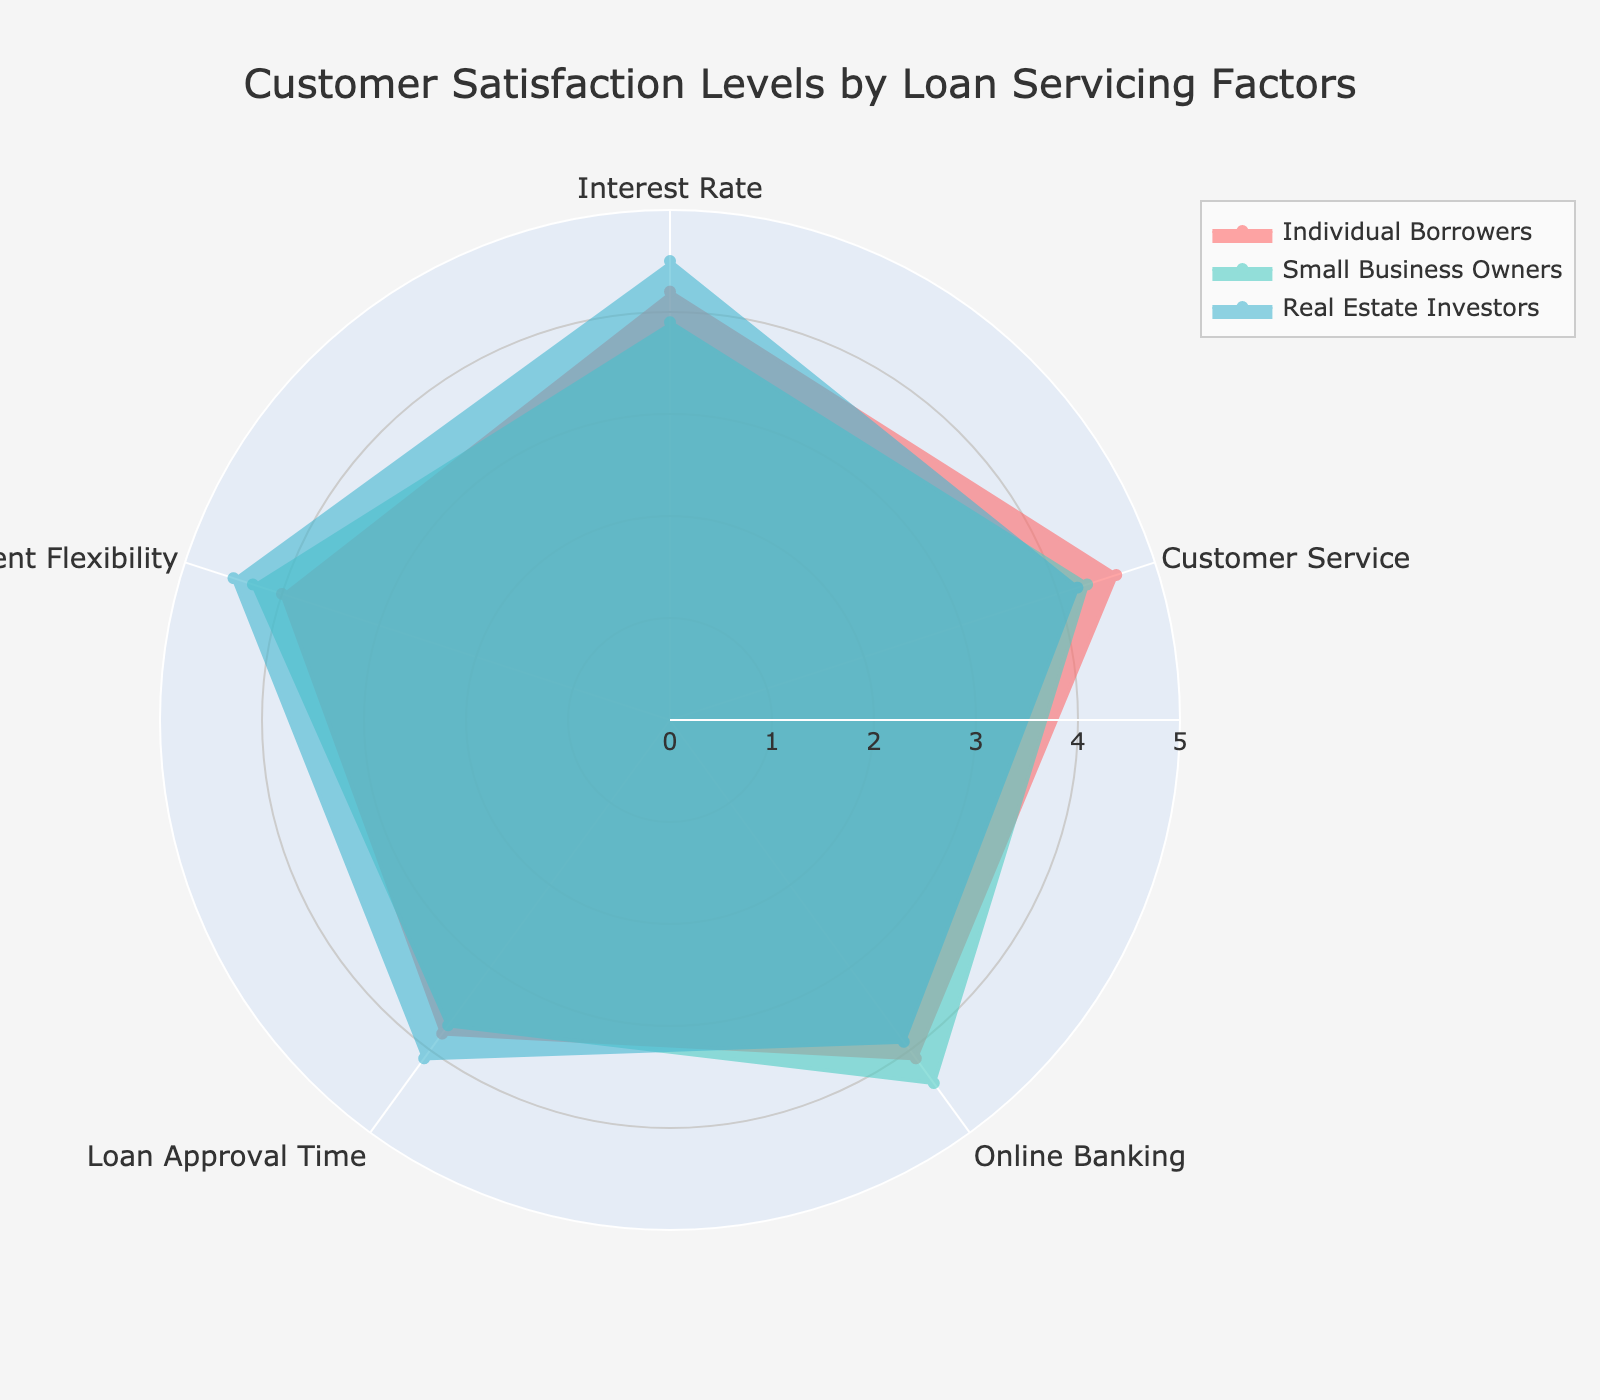What is the title of the radar chart? The title of a chart is typically found at the top, summarizing the chart's content. Here, it reads "Customer Satisfaction Levels by Loan Servicing Factors."
Answer: Customer Satisfaction Levels by Loan Servicing Factors How many customer groups are represented in the radar chart? The legend often indicates the groups represented. Here, there are three: Individual Borrowers, Small Business Owners, and Real Estate Investors.
Answer: 3 Which customer group has the highest satisfaction level for "Interest Rate"? Review the points for "Interest Rate" in the chart. The highest value is 4.5, which belongs to the Real Estate Investors.
Answer: Real Estate Investors What's the average satisfaction level across all factors for Individual Borrowers? Sum the values for Individual Borrowers across the five factors and divide by 5. (4.2 + 4.6 + 4.1 + 3.8 + 4.0) / 5 = 20.7 / 5 = 4.14.
Answer: 4.14 Which factor has the lowest satisfaction level for Small Business Owners? Look at the values for Small Business Owners. The lowest value is 3.7, which corresponds to "Loan Approval Time."
Answer: Loan Approval Time What is the difference in satisfaction levels for "Customer Service" between Individual Borrowers and Real Estate Investors? Subtract the "Customer Service" value for Real Estate Investors (4.2) from Individual Borrowers (4.6). 4.6 - 4.2 = 0.4.
Answer: 0.4 Which customer group shows the most balanced satisfaction across all factors? Compare the ranges of values across each group. Small Business Owners have values from 3.7 to 4.4, showing the smallest range (4.4 - 3.7 = 0.7).
Answer: Small Business Owners In terms of "Repayment Flexibility," which group is more satisfied: Small Business Owners or Real Estate Investors? Compare the values: Small Business Owners have 4.3 and Real Estate Investors have 4.5. Real Estate Investors have a higher value.
Answer: Real Estate Investors Which category shows the highest satisfaction level among all groups and factors? Examine all the values across the chart. The highest value is 4.6 for "Customer Service" by Individual Borrowers.
Answer: Customer Service by Individual Borrowers What is the range of satisfaction levels for Online Banking across all groups? Calculate the max and min values for Online Banking. Max is 4.4 (Small Business Owners) and min is 3.9 (Real Estate Investors), so the range is 4.4 - 3.9 = 0.5.
Answer: 0.5 